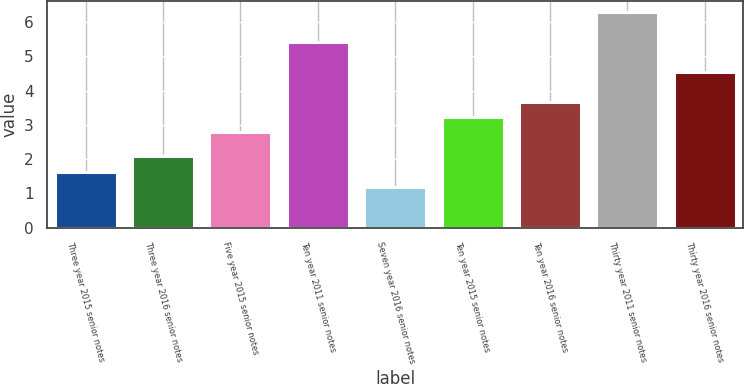<chart> <loc_0><loc_0><loc_500><loc_500><bar_chart><fcel>Three year 2015 senior notes<fcel>Three year 2016 senior notes<fcel>Five year 2015 senior notes<fcel>Ten year 2011 senior notes<fcel>Seven year 2016 senior notes<fcel>Ten year 2015 senior notes<fcel>Ten year 2016 senior notes<fcel>Thirty year 2011 senior notes<fcel>Thirty year 2016 senior notes<nl><fcel>1.64<fcel>2.08<fcel>2.79<fcel>5.43<fcel>1.2<fcel>3.23<fcel>3.67<fcel>6.31<fcel>4.55<nl></chart> 